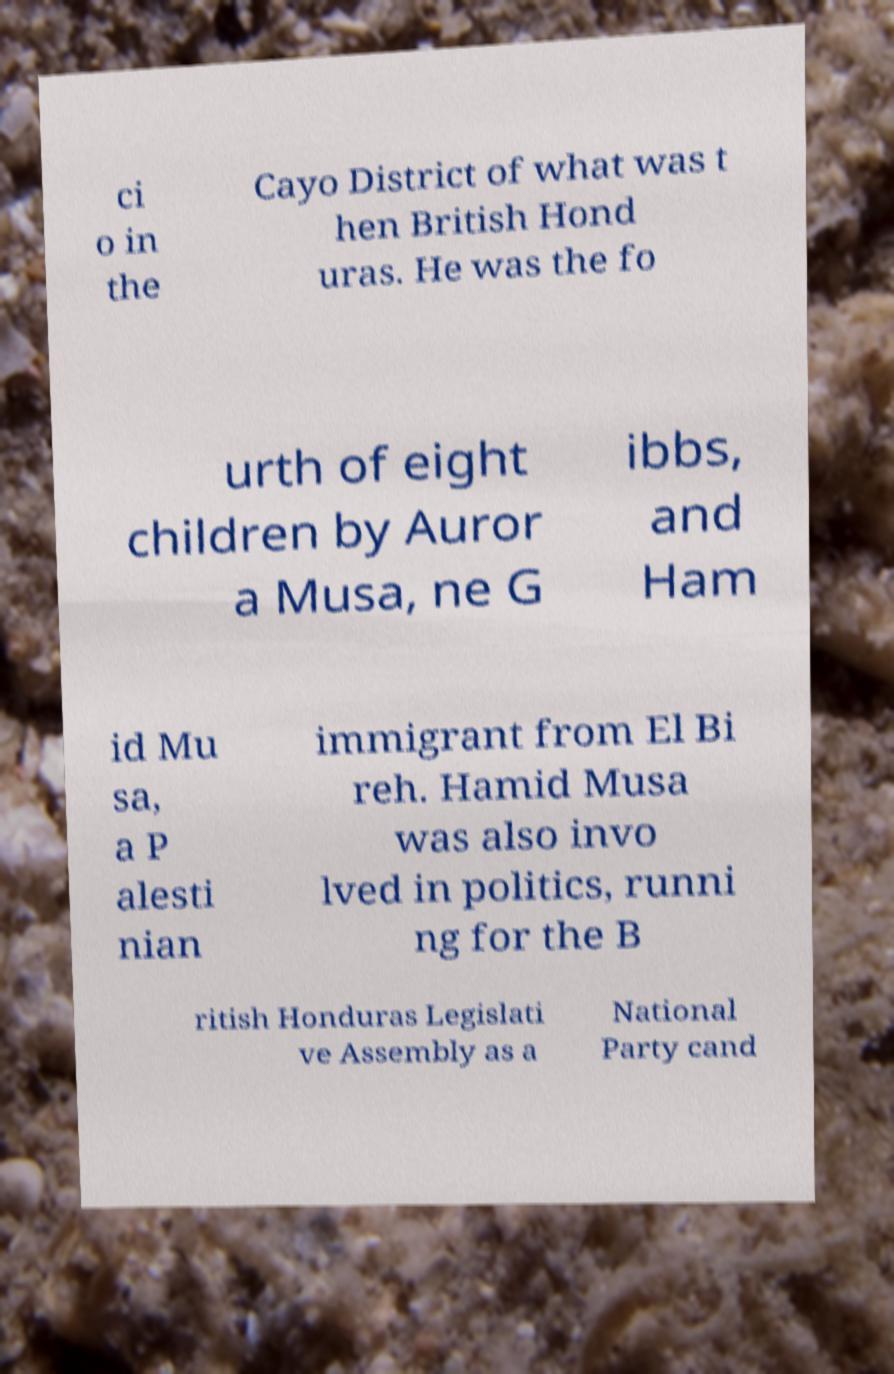Could you assist in decoding the text presented in this image and type it out clearly? ci o in the Cayo District of what was t hen British Hond uras. He was the fo urth of eight children by Auror a Musa, ne G ibbs, and Ham id Mu sa, a P alesti nian immigrant from El Bi reh. Hamid Musa was also invo lved in politics, runni ng for the B ritish Honduras Legislati ve Assembly as a National Party cand 